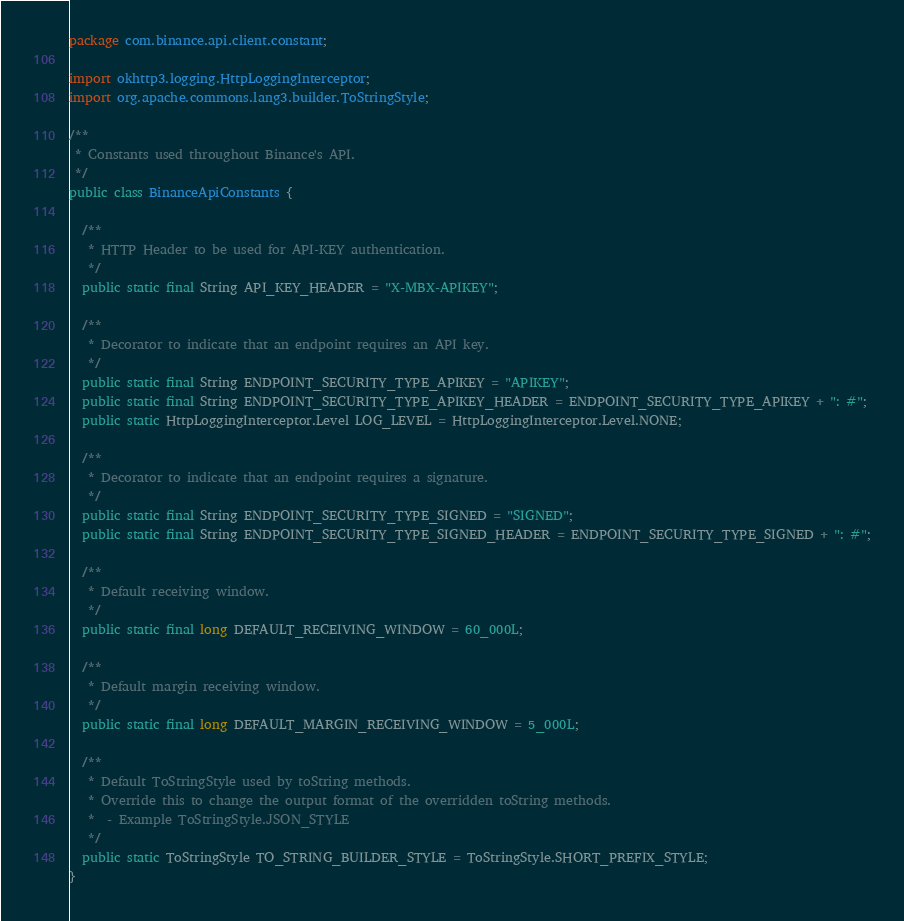<code> <loc_0><loc_0><loc_500><loc_500><_Java_>package com.binance.api.client.constant;

import okhttp3.logging.HttpLoggingInterceptor;
import org.apache.commons.lang3.builder.ToStringStyle;

/**
 * Constants used throughout Binance's API.
 */
public class BinanceApiConstants {

  /**
   * HTTP Header to be used for API-KEY authentication.
   */
  public static final String API_KEY_HEADER = "X-MBX-APIKEY";

  /**
   * Decorator to indicate that an endpoint requires an API key.
   */
  public static final String ENDPOINT_SECURITY_TYPE_APIKEY = "APIKEY";
  public static final String ENDPOINT_SECURITY_TYPE_APIKEY_HEADER = ENDPOINT_SECURITY_TYPE_APIKEY + ": #";
  public static HttpLoggingInterceptor.Level LOG_LEVEL = HttpLoggingInterceptor.Level.NONE;

  /**
   * Decorator to indicate that an endpoint requires a signature.
   */
  public static final String ENDPOINT_SECURITY_TYPE_SIGNED = "SIGNED";
  public static final String ENDPOINT_SECURITY_TYPE_SIGNED_HEADER = ENDPOINT_SECURITY_TYPE_SIGNED + ": #";

  /**
   * Default receiving window.
   */
  public static final long DEFAULT_RECEIVING_WINDOW = 60_000L;

  /**
   * Default margin receiving window.
   */
  public static final long DEFAULT_MARGIN_RECEIVING_WINDOW = 5_000L;

  /**
   * Default ToStringStyle used by toString methods.
   * Override this to change the output format of the overridden toString methods.
   *  - Example ToStringStyle.JSON_STYLE
   */
  public static ToStringStyle TO_STRING_BUILDER_STYLE = ToStringStyle.SHORT_PREFIX_STYLE;
}
</code> 